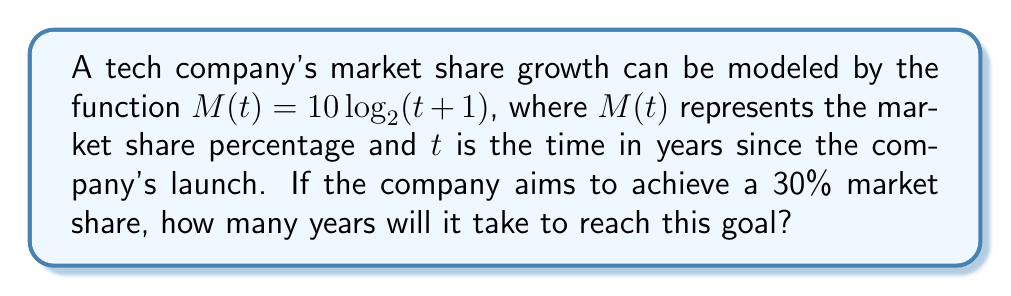Teach me how to tackle this problem. To solve this problem, we need to follow these steps:

1. Set up the equation:
   We want to find $t$ when $M(t) = 30$
   $$30 = 10 \log_2(t+1)$$

2. Isolate the logarithm:
   $$3 = \log_2(t+1)$$

3. Apply the inverse function (exponential) to both sides:
   $$2^3 = t+1$$

4. Simplify:
   $$8 = t+1$$

5. Solve for $t$:
   $$t = 8-1 = 7$$

Therefore, it will take 7 years for the company to reach a 30% market share.

This logarithmic model is useful in marketing as it represents the common pattern of rapid initial growth followed by a slower increase as the market becomes saturated.
Answer: 7 years 